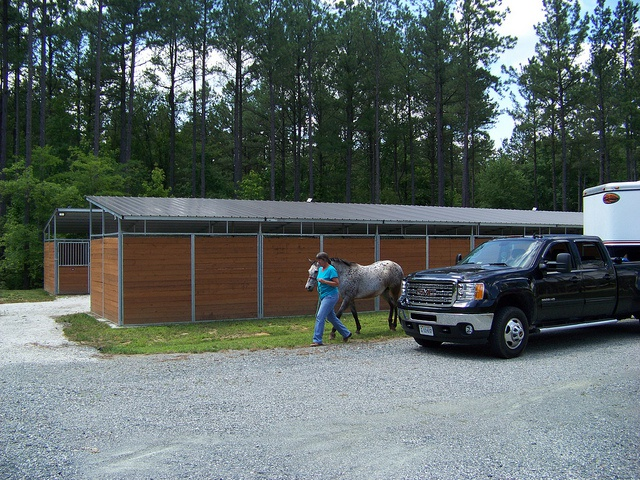Describe the objects in this image and their specific colors. I can see truck in darkgreen, black, and gray tones, horse in darkgreen, black, gray, darkgray, and maroon tones, and people in darkgreen, blue, navy, and black tones in this image. 